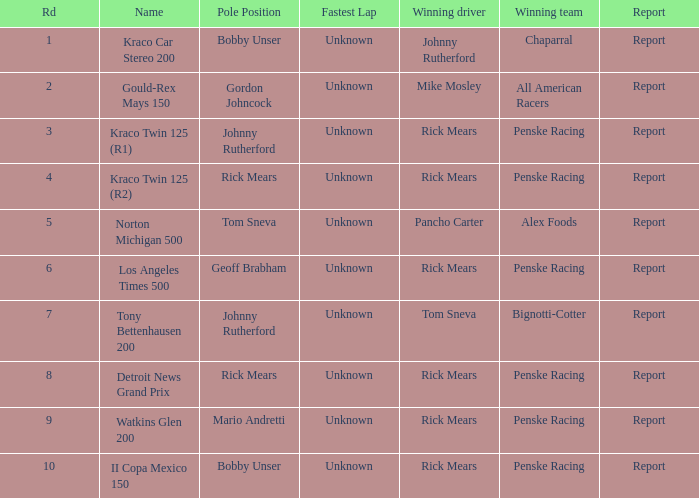What are the races that johnny rutherford has won? Kraco Car Stereo 200. 